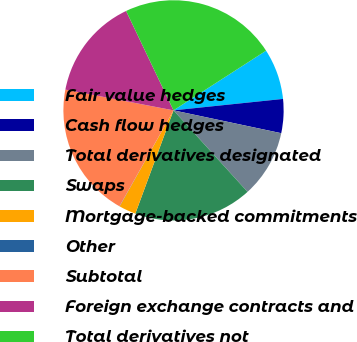Convert chart to OTSL. <chart><loc_0><loc_0><loc_500><loc_500><pie_chart><fcel>Fair value hedges<fcel>Cash flow hedges<fcel>Total derivatives designated<fcel>Swaps<fcel>Mortgage-backed commitments<fcel>Other<fcel>Subtotal<fcel>Foreign exchange contracts and<fcel>Total derivatives not<nl><fcel>7.46%<fcel>4.98%<fcel>9.94%<fcel>17.37%<fcel>2.5%<fcel>0.03%<fcel>19.85%<fcel>14.9%<fcel>22.97%<nl></chart> 